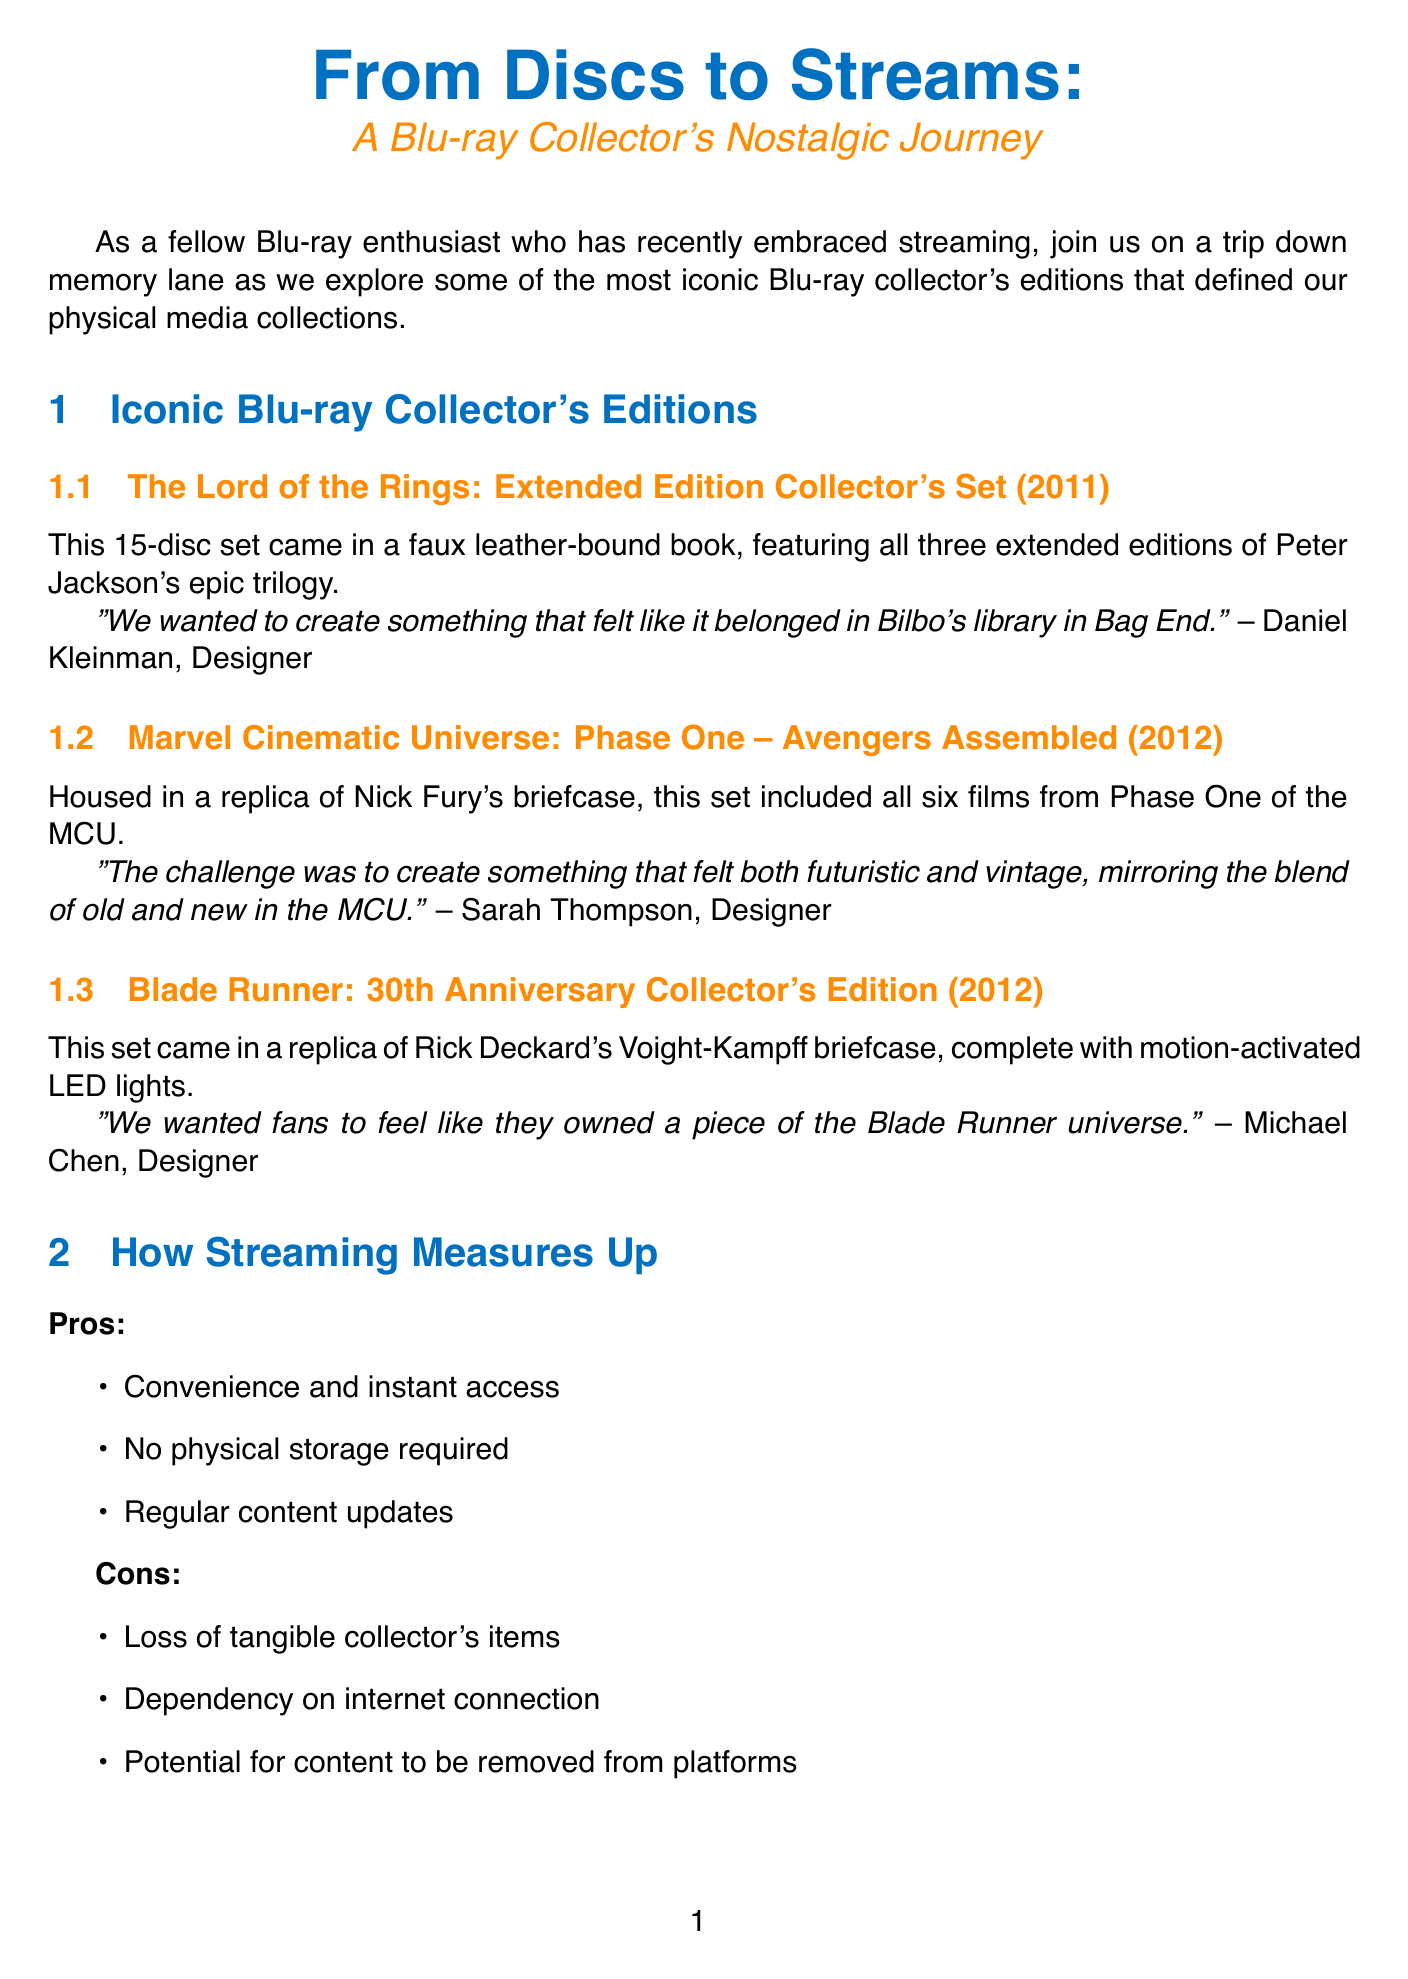What is the release year of "The Lord of the Rings: Extended Edition Collector's Set"? The release year of the set is mentioned in the document as 2011.
Answer: 2011 Who designed the "Blade Runner: 30th Anniversary Collector's Edition"? The designer's name is provided in the document as Michael Chen.
Answer: Michael Chen What is a pro of streaming mentioned in the document? The document lists advantages of streaming, one of which is "Convenience and instant access".
Answer: Convenience and instant access What material was the "Marvel Cinematic Universe: Phase One – Avengers Assembled" housed in? The document states that the set was housed in a "replica of Nick Fury's briefcase".
Answer: replica of Nick Fury's briefcase What is one tip for preserving the collector's experience? The document offers tips, including "Create digital libraries with high-resolution scans of your favorite box art."
Answer: Create digital libraries with high-resolution scans of your favorite box art What does Dr. Amanda Rodriguez think about the future of physical media? Her opinion in the document suggests that there may be a resurgence of limited edition physical releases, similar to vinyl records.
Answer: resurgence of limited edition physical releases What did Daniel Kleinman want to evoke with the "The Lord of the Rings: Extended Edition Collector's Set"? The document quotes him saying they wanted to create something that felt like it belonged in "Bilbo's library in Bag End."
Answer: Bilbo's library in Bag End How many films are included in the "Marvel Cinematic Universe: Phase One – Avengers Assembled"? The document states that the set included "all six films from Phase One of the MCU."
Answer: six films 